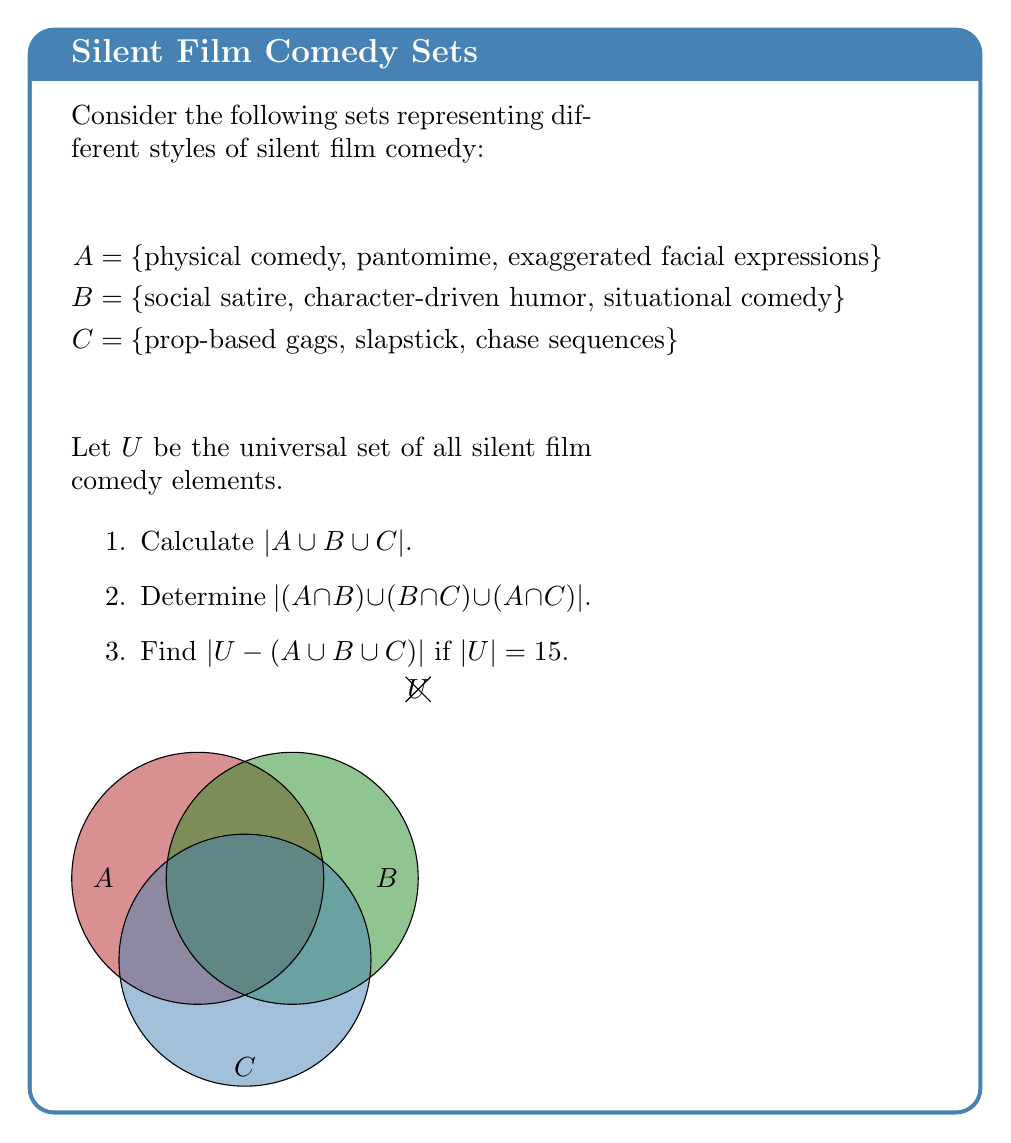Can you solve this math problem? Let's approach this problem step-by-step:

1. To calculate $|A \cup B \cup C|$:
   First, list all unique elements: 
   {physical comedy, pantomime, exaggerated facial expressions, social satire, character-driven humor, situational comedy, prop-based gags, slapstick, chase sequences}
   Count these elements: $|A \cup B \cup C| = 9$

2. To determine $|(A \cap B) \cup (B \cap C) \cup (A \cap C)|$:
   Observe that A, B, and C are mutually exclusive (no common elements).
   Therefore, $A \cap B = B \cap C = A \cap C = \emptyset$
   $|(A \cap B) \cup (B \cap C) \cup (A \cap C)| = |\emptyset| = 0$

3. To find $|U - (A \cup B \cup C)|$:
   We know $|U| = 15$ and $|A \cup B \cup C| = 9$
   $|U - (A \cup B \cup C)| = |U| - |A \cup B \cup C| = 15 - 9 = 6$

This result suggests there are 6 other elements in the universal set of silent film comedy styles not included in sets A, B, or C. These could represent other unique aspects of silent film comedy, such as visual puns, irony, or parody, which were also prevalent in the era but not categorized in the given sets.
Answer: 1) 9
2) 0
3) 6 